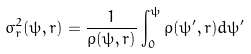Convert formula to latex. <formula><loc_0><loc_0><loc_500><loc_500>\sigma _ { r } ^ { 2 } ( \psi , r ) = \frac { 1 } { \rho ( \psi , r ) } \int _ { 0 } ^ { \psi } \rho ( \psi ^ { \prime } , r ) d \psi ^ { \prime }</formula> 